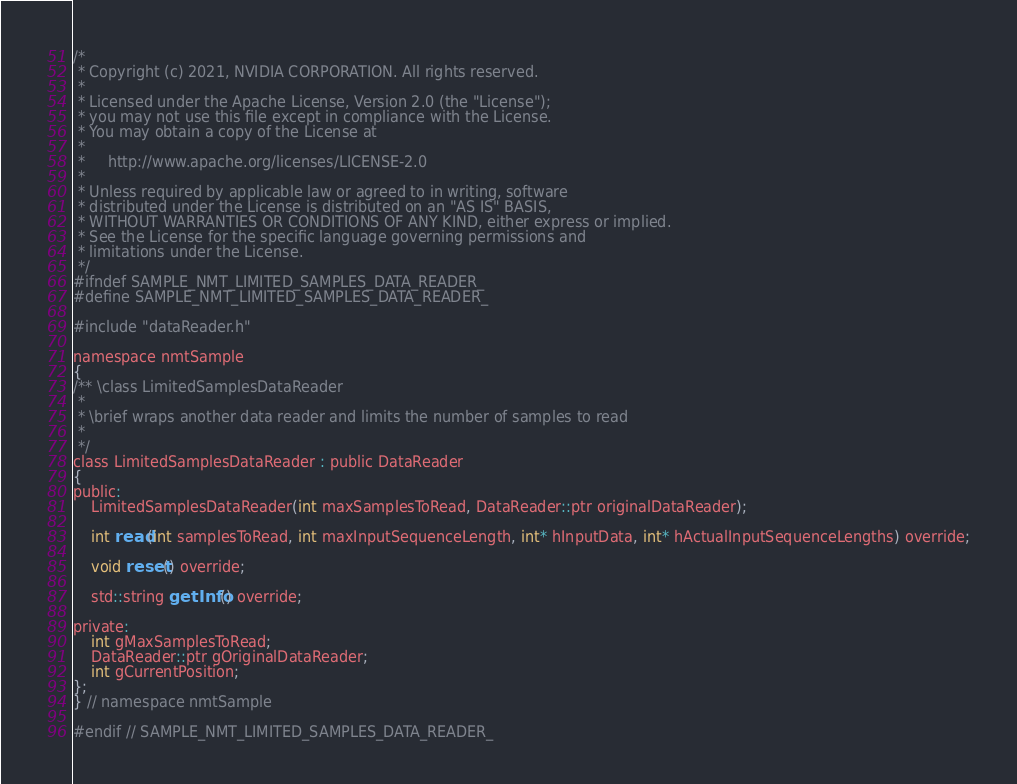Convert code to text. <code><loc_0><loc_0><loc_500><loc_500><_C_>/*
 * Copyright (c) 2021, NVIDIA CORPORATION. All rights reserved.
 *
 * Licensed under the Apache License, Version 2.0 (the "License");
 * you may not use this file except in compliance with the License.
 * You may obtain a copy of the License at
 *
 *     http://www.apache.org/licenses/LICENSE-2.0
 *
 * Unless required by applicable law or agreed to in writing, software
 * distributed under the License is distributed on an "AS IS" BASIS,
 * WITHOUT WARRANTIES OR CONDITIONS OF ANY KIND, either express or implied.
 * See the License for the specific language governing permissions and
 * limitations under the License.
 */
#ifndef SAMPLE_NMT_LIMITED_SAMPLES_DATA_READER_
#define SAMPLE_NMT_LIMITED_SAMPLES_DATA_READER_

#include "dataReader.h"

namespace nmtSample
{
/** \class LimitedSamplesDataReader
 *
 * \brief wraps another data reader and limits the number of samples to read
 *
 */
class LimitedSamplesDataReader : public DataReader
{
public:
    LimitedSamplesDataReader(int maxSamplesToRead, DataReader::ptr originalDataReader);

    int read(int samplesToRead, int maxInputSequenceLength, int* hInputData, int* hActualInputSequenceLengths) override;

    void reset() override;

    std::string getInfo() override;

private:
    int gMaxSamplesToRead;
    DataReader::ptr gOriginalDataReader;
    int gCurrentPosition;
};
} // namespace nmtSample

#endif // SAMPLE_NMT_LIMITED_SAMPLES_DATA_READER_
</code> 